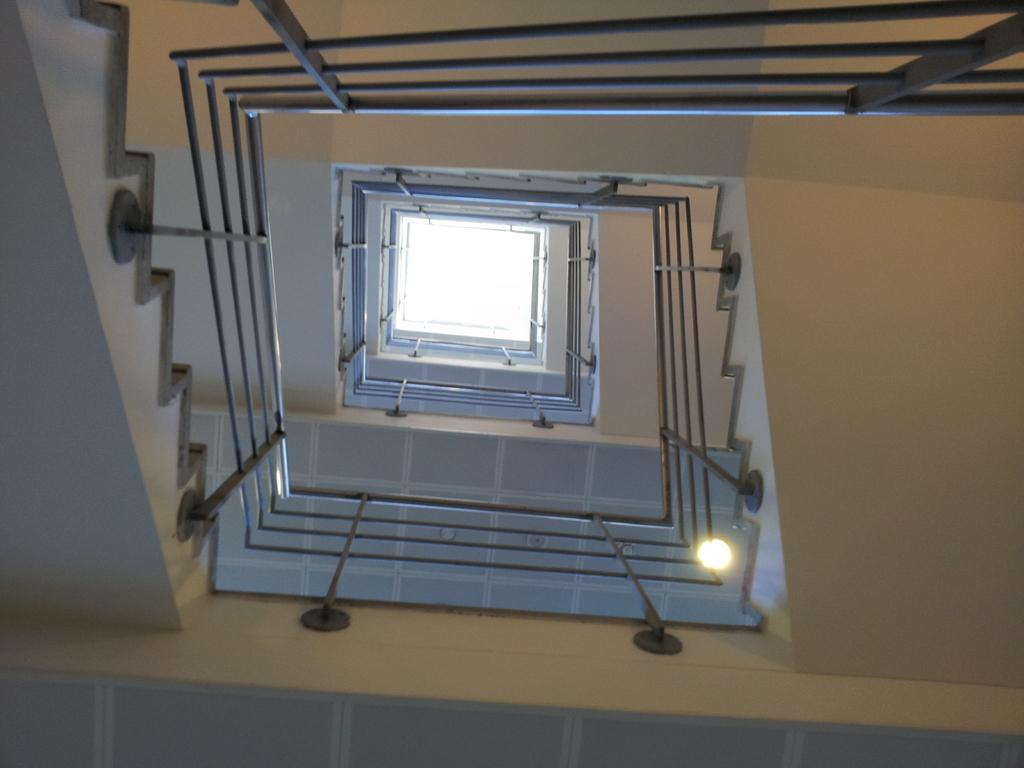What type of location is depicted in the image? The image is an inside view of a building. What architectural feature can be seen in the image? There are stairs in the image. What safety feature is present in the image? There is a railing in the image. What part of the building is visible in the image? The roof is visible in the image. What provides illumination in the image? There is a light source in the image. What type of stew is being cooked in the image? There is no stew present in the image; it is an inside view of a building with stairs, a railing, the roof, and a light source. What quarter is the building located in the image? The image does not specify the location or quarter of the building. 